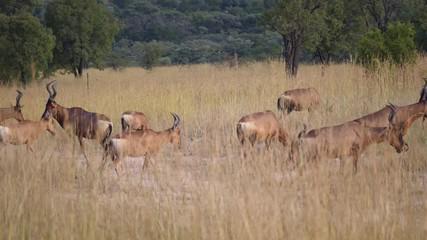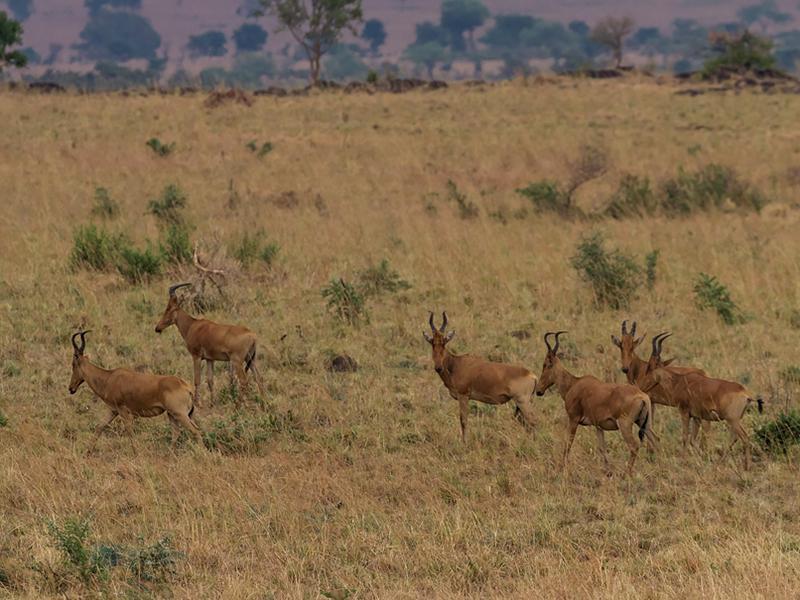The first image is the image on the left, the second image is the image on the right. Analyze the images presented: Is the assertion "Zebras are near the horned animals in the image on the right." valid? Answer yes or no. No. The first image is the image on the left, the second image is the image on the right. Assess this claim about the two images: "An image includes multiple zebra and at least one brown horned animal.". Correct or not? Answer yes or no. No. 